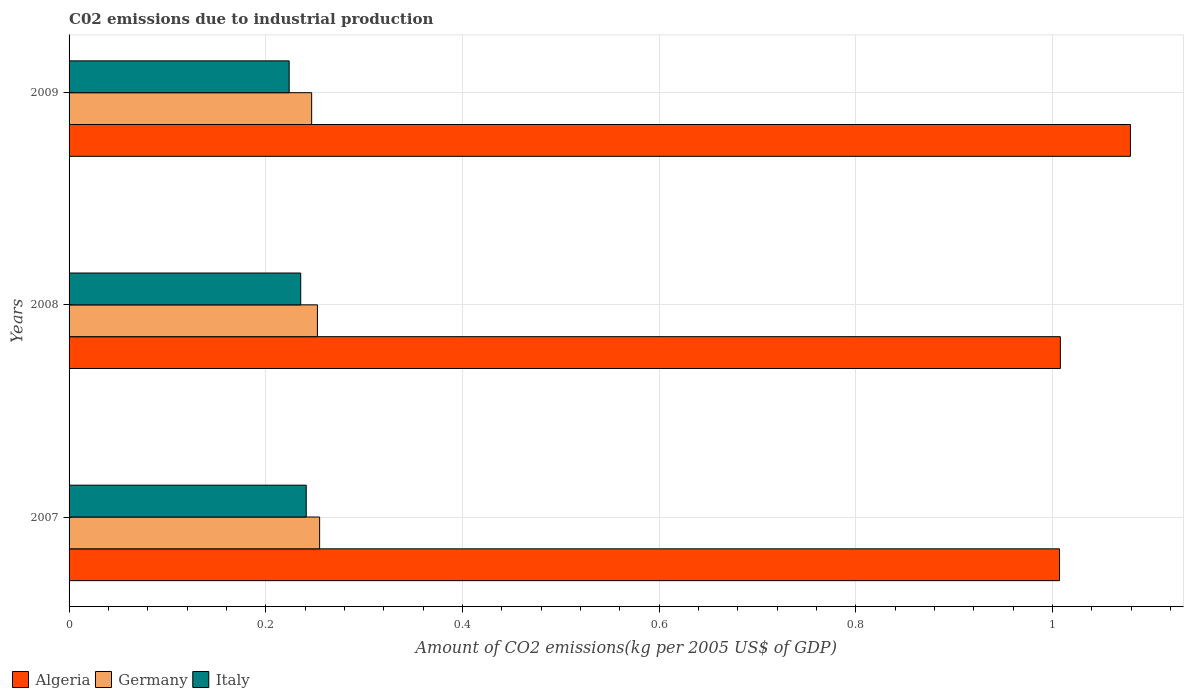How many different coloured bars are there?
Provide a succinct answer. 3. How many groups of bars are there?
Ensure brevity in your answer.  3. Are the number of bars on each tick of the Y-axis equal?
Your answer should be very brief. Yes. How many bars are there on the 3rd tick from the top?
Keep it short and to the point. 3. What is the amount of CO2 emitted due to industrial production in Italy in 2007?
Your response must be concise. 0.24. Across all years, what is the maximum amount of CO2 emitted due to industrial production in Germany?
Offer a very short reply. 0.25. Across all years, what is the minimum amount of CO2 emitted due to industrial production in Germany?
Your response must be concise. 0.25. In which year was the amount of CO2 emitted due to industrial production in Germany maximum?
Provide a succinct answer. 2007. What is the total amount of CO2 emitted due to industrial production in Algeria in the graph?
Give a very brief answer. 3.09. What is the difference between the amount of CO2 emitted due to industrial production in Germany in 2008 and that in 2009?
Provide a succinct answer. 0.01. What is the difference between the amount of CO2 emitted due to industrial production in Algeria in 2009 and the amount of CO2 emitted due to industrial production in Germany in 2008?
Offer a very short reply. 0.83. What is the average amount of CO2 emitted due to industrial production in Italy per year?
Provide a short and direct response. 0.23. In the year 2007, what is the difference between the amount of CO2 emitted due to industrial production in Algeria and amount of CO2 emitted due to industrial production in Germany?
Offer a very short reply. 0.75. What is the ratio of the amount of CO2 emitted due to industrial production in Italy in 2008 to that in 2009?
Provide a succinct answer. 1.05. Is the amount of CO2 emitted due to industrial production in Algeria in 2007 less than that in 2008?
Provide a short and direct response. Yes. What is the difference between the highest and the second highest amount of CO2 emitted due to industrial production in Germany?
Offer a terse response. 0. What is the difference between the highest and the lowest amount of CO2 emitted due to industrial production in Italy?
Offer a very short reply. 0.02. Is the sum of the amount of CO2 emitted due to industrial production in Italy in 2008 and 2009 greater than the maximum amount of CO2 emitted due to industrial production in Germany across all years?
Ensure brevity in your answer.  Yes. What does the 1st bar from the top in 2009 represents?
Keep it short and to the point. Italy. How many bars are there?
Your answer should be very brief. 9. Does the graph contain grids?
Your answer should be very brief. Yes. Where does the legend appear in the graph?
Your answer should be compact. Bottom left. How many legend labels are there?
Your response must be concise. 3. What is the title of the graph?
Your response must be concise. C02 emissions due to industrial production. What is the label or title of the X-axis?
Ensure brevity in your answer.  Amount of CO2 emissions(kg per 2005 US$ of GDP). What is the label or title of the Y-axis?
Provide a succinct answer. Years. What is the Amount of CO2 emissions(kg per 2005 US$ of GDP) in Algeria in 2007?
Your answer should be very brief. 1.01. What is the Amount of CO2 emissions(kg per 2005 US$ of GDP) of Germany in 2007?
Your answer should be very brief. 0.25. What is the Amount of CO2 emissions(kg per 2005 US$ of GDP) of Italy in 2007?
Your answer should be compact. 0.24. What is the Amount of CO2 emissions(kg per 2005 US$ of GDP) of Algeria in 2008?
Your response must be concise. 1.01. What is the Amount of CO2 emissions(kg per 2005 US$ of GDP) in Germany in 2008?
Ensure brevity in your answer.  0.25. What is the Amount of CO2 emissions(kg per 2005 US$ of GDP) of Italy in 2008?
Offer a very short reply. 0.24. What is the Amount of CO2 emissions(kg per 2005 US$ of GDP) in Algeria in 2009?
Offer a very short reply. 1.08. What is the Amount of CO2 emissions(kg per 2005 US$ of GDP) of Germany in 2009?
Offer a terse response. 0.25. What is the Amount of CO2 emissions(kg per 2005 US$ of GDP) in Italy in 2009?
Your response must be concise. 0.22. Across all years, what is the maximum Amount of CO2 emissions(kg per 2005 US$ of GDP) in Algeria?
Offer a very short reply. 1.08. Across all years, what is the maximum Amount of CO2 emissions(kg per 2005 US$ of GDP) in Germany?
Keep it short and to the point. 0.25. Across all years, what is the maximum Amount of CO2 emissions(kg per 2005 US$ of GDP) in Italy?
Your response must be concise. 0.24. Across all years, what is the minimum Amount of CO2 emissions(kg per 2005 US$ of GDP) in Algeria?
Keep it short and to the point. 1.01. Across all years, what is the minimum Amount of CO2 emissions(kg per 2005 US$ of GDP) of Germany?
Offer a terse response. 0.25. Across all years, what is the minimum Amount of CO2 emissions(kg per 2005 US$ of GDP) in Italy?
Offer a very short reply. 0.22. What is the total Amount of CO2 emissions(kg per 2005 US$ of GDP) of Algeria in the graph?
Your answer should be compact. 3.09. What is the total Amount of CO2 emissions(kg per 2005 US$ of GDP) in Germany in the graph?
Offer a very short reply. 0.75. What is the total Amount of CO2 emissions(kg per 2005 US$ of GDP) in Italy in the graph?
Give a very brief answer. 0.7. What is the difference between the Amount of CO2 emissions(kg per 2005 US$ of GDP) in Algeria in 2007 and that in 2008?
Provide a succinct answer. -0. What is the difference between the Amount of CO2 emissions(kg per 2005 US$ of GDP) in Germany in 2007 and that in 2008?
Ensure brevity in your answer.  0. What is the difference between the Amount of CO2 emissions(kg per 2005 US$ of GDP) in Italy in 2007 and that in 2008?
Offer a terse response. 0.01. What is the difference between the Amount of CO2 emissions(kg per 2005 US$ of GDP) of Algeria in 2007 and that in 2009?
Provide a short and direct response. -0.07. What is the difference between the Amount of CO2 emissions(kg per 2005 US$ of GDP) of Germany in 2007 and that in 2009?
Provide a succinct answer. 0.01. What is the difference between the Amount of CO2 emissions(kg per 2005 US$ of GDP) of Italy in 2007 and that in 2009?
Provide a succinct answer. 0.02. What is the difference between the Amount of CO2 emissions(kg per 2005 US$ of GDP) of Algeria in 2008 and that in 2009?
Your answer should be very brief. -0.07. What is the difference between the Amount of CO2 emissions(kg per 2005 US$ of GDP) of Germany in 2008 and that in 2009?
Your response must be concise. 0.01. What is the difference between the Amount of CO2 emissions(kg per 2005 US$ of GDP) of Italy in 2008 and that in 2009?
Your answer should be very brief. 0.01. What is the difference between the Amount of CO2 emissions(kg per 2005 US$ of GDP) in Algeria in 2007 and the Amount of CO2 emissions(kg per 2005 US$ of GDP) in Germany in 2008?
Provide a succinct answer. 0.75. What is the difference between the Amount of CO2 emissions(kg per 2005 US$ of GDP) in Algeria in 2007 and the Amount of CO2 emissions(kg per 2005 US$ of GDP) in Italy in 2008?
Your answer should be very brief. 0.77. What is the difference between the Amount of CO2 emissions(kg per 2005 US$ of GDP) in Germany in 2007 and the Amount of CO2 emissions(kg per 2005 US$ of GDP) in Italy in 2008?
Give a very brief answer. 0.02. What is the difference between the Amount of CO2 emissions(kg per 2005 US$ of GDP) of Algeria in 2007 and the Amount of CO2 emissions(kg per 2005 US$ of GDP) of Germany in 2009?
Provide a succinct answer. 0.76. What is the difference between the Amount of CO2 emissions(kg per 2005 US$ of GDP) of Algeria in 2007 and the Amount of CO2 emissions(kg per 2005 US$ of GDP) of Italy in 2009?
Give a very brief answer. 0.78. What is the difference between the Amount of CO2 emissions(kg per 2005 US$ of GDP) in Germany in 2007 and the Amount of CO2 emissions(kg per 2005 US$ of GDP) in Italy in 2009?
Give a very brief answer. 0.03. What is the difference between the Amount of CO2 emissions(kg per 2005 US$ of GDP) of Algeria in 2008 and the Amount of CO2 emissions(kg per 2005 US$ of GDP) of Germany in 2009?
Offer a very short reply. 0.76. What is the difference between the Amount of CO2 emissions(kg per 2005 US$ of GDP) of Algeria in 2008 and the Amount of CO2 emissions(kg per 2005 US$ of GDP) of Italy in 2009?
Provide a short and direct response. 0.78. What is the difference between the Amount of CO2 emissions(kg per 2005 US$ of GDP) of Germany in 2008 and the Amount of CO2 emissions(kg per 2005 US$ of GDP) of Italy in 2009?
Offer a very short reply. 0.03. What is the average Amount of CO2 emissions(kg per 2005 US$ of GDP) of Algeria per year?
Make the answer very short. 1.03. What is the average Amount of CO2 emissions(kg per 2005 US$ of GDP) in Germany per year?
Your answer should be compact. 0.25. What is the average Amount of CO2 emissions(kg per 2005 US$ of GDP) of Italy per year?
Your answer should be very brief. 0.23. In the year 2007, what is the difference between the Amount of CO2 emissions(kg per 2005 US$ of GDP) in Algeria and Amount of CO2 emissions(kg per 2005 US$ of GDP) in Germany?
Provide a short and direct response. 0.75. In the year 2007, what is the difference between the Amount of CO2 emissions(kg per 2005 US$ of GDP) of Algeria and Amount of CO2 emissions(kg per 2005 US$ of GDP) of Italy?
Offer a terse response. 0.77. In the year 2007, what is the difference between the Amount of CO2 emissions(kg per 2005 US$ of GDP) in Germany and Amount of CO2 emissions(kg per 2005 US$ of GDP) in Italy?
Provide a succinct answer. 0.01. In the year 2008, what is the difference between the Amount of CO2 emissions(kg per 2005 US$ of GDP) in Algeria and Amount of CO2 emissions(kg per 2005 US$ of GDP) in Germany?
Make the answer very short. 0.76. In the year 2008, what is the difference between the Amount of CO2 emissions(kg per 2005 US$ of GDP) of Algeria and Amount of CO2 emissions(kg per 2005 US$ of GDP) of Italy?
Your answer should be very brief. 0.77. In the year 2008, what is the difference between the Amount of CO2 emissions(kg per 2005 US$ of GDP) in Germany and Amount of CO2 emissions(kg per 2005 US$ of GDP) in Italy?
Offer a very short reply. 0.02. In the year 2009, what is the difference between the Amount of CO2 emissions(kg per 2005 US$ of GDP) in Algeria and Amount of CO2 emissions(kg per 2005 US$ of GDP) in Germany?
Provide a short and direct response. 0.83. In the year 2009, what is the difference between the Amount of CO2 emissions(kg per 2005 US$ of GDP) in Algeria and Amount of CO2 emissions(kg per 2005 US$ of GDP) in Italy?
Your response must be concise. 0.86. In the year 2009, what is the difference between the Amount of CO2 emissions(kg per 2005 US$ of GDP) of Germany and Amount of CO2 emissions(kg per 2005 US$ of GDP) of Italy?
Offer a very short reply. 0.02. What is the ratio of the Amount of CO2 emissions(kg per 2005 US$ of GDP) of Algeria in 2007 to that in 2008?
Provide a short and direct response. 1. What is the ratio of the Amount of CO2 emissions(kg per 2005 US$ of GDP) of Germany in 2007 to that in 2008?
Provide a short and direct response. 1.01. What is the ratio of the Amount of CO2 emissions(kg per 2005 US$ of GDP) of Italy in 2007 to that in 2008?
Keep it short and to the point. 1.02. What is the ratio of the Amount of CO2 emissions(kg per 2005 US$ of GDP) in Algeria in 2007 to that in 2009?
Ensure brevity in your answer.  0.93. What is the ratio of the Amount of CO2 emissions(kg per 2005 US$ of GDP) of Germany in 2007 to that in 2009?
Provide a succinct answer. 1.03. What is the ratio of the Amount of CO2 emissions(kg per 2005 US$ of GDP) of Italy in 2007 to that in 2009?
Provide a succinct answer. 1.08. What is the ratio of the Amount of CO2 emissions(kg per 2005 US$ of GDP) in Algeria in 2008 to that in 2009?
Make the answer very short. 0.93. What is the ratio of the Amount of CO2 emissions(kg per 2005 US$ of GDP) of Germany in 2008 to that in 2009?
Make the answer very short. 1.02. What is the ratio of the Amount of CO2 emissions(kg per 2005 US$ of GDP) in Italy in 2008 to that in 2009?
Offer a terse response. 1.05. What is the difference between the highest and the second highest Amount of CO2 emissions(kg per 2005 US$ of GDP) of Algeria?
Your answer should be compact. 0.07. What is the difference between the highest and the second highest Amount of CO2 emissions(kg per 2005 US$ of GDP) of Germany?
Ensure brevity in your answer.  0. What is the difference between the highest and the second highest Amount of CO2 emissions(kg per 2005 US$ of GDP) in Italy?
Your answer should be very brief. 0.01. What is the difference between the highest and the lowest Amount of CO2 emissions(kg per 2005 US$ of GDP) of Algeria?
Your response must be concise. 0.07. What is the difference between the highest and the lowest Amount of CO2 emissions(kg per 2005 US$ of GDP) in Germany?
Offer a very short reply. 0.01. What is the difference between the highest and the lowest Amount of CO2 emissions(kg per 2005 US$ of GDP) in Italy?
Provide a short and direct response. 0.02. 